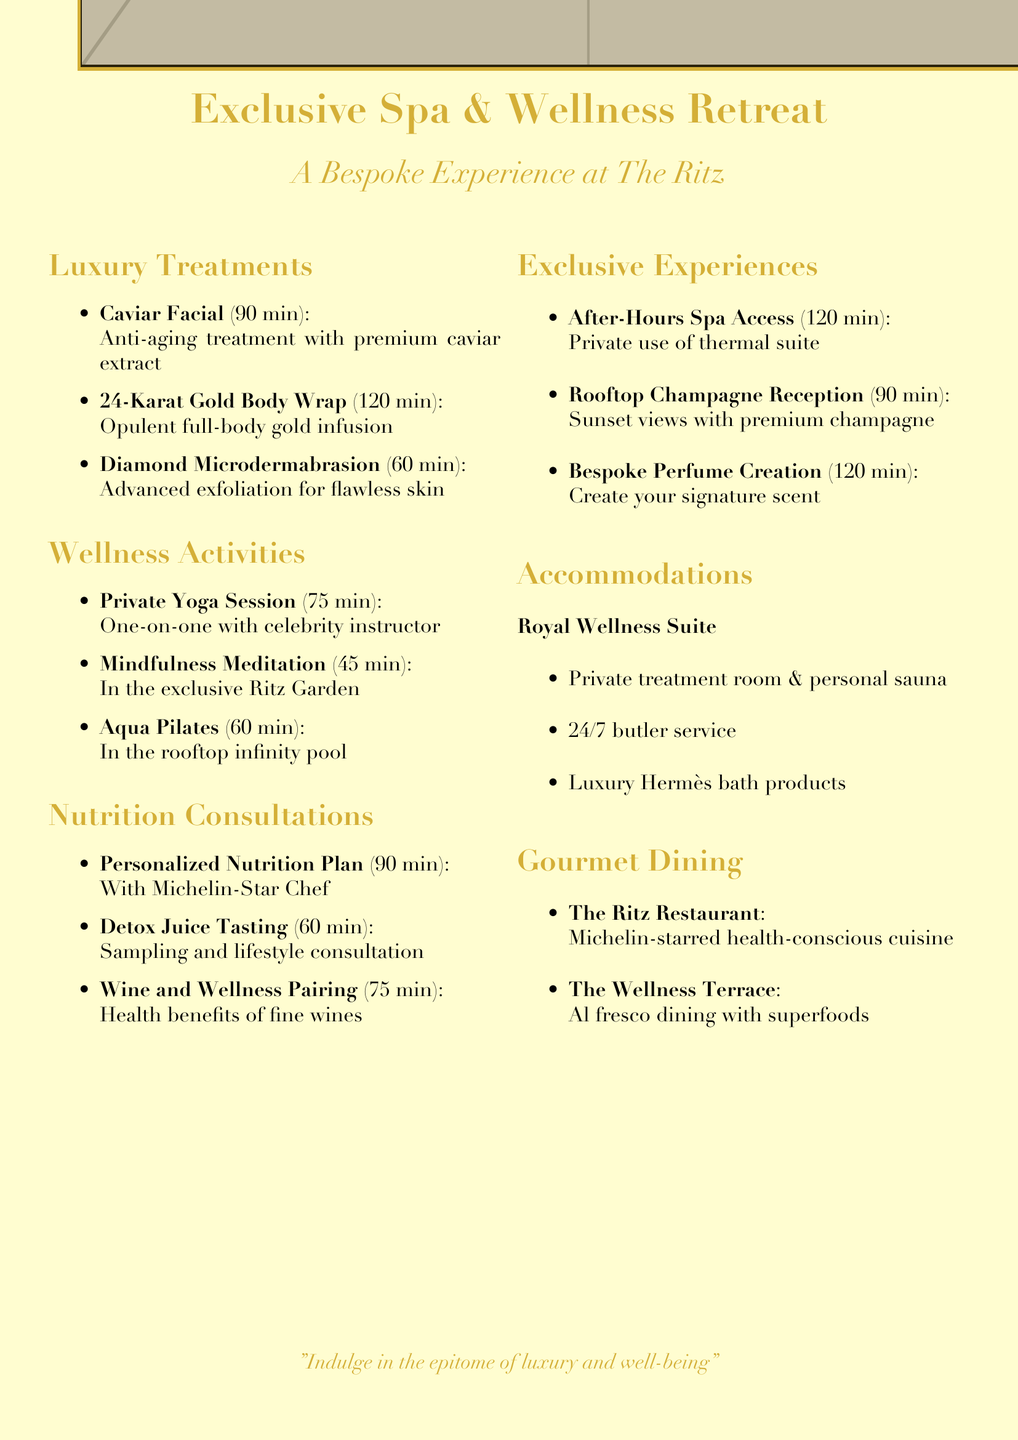What is the duration of the Caviar Facial? The duration of the Caviar Facial is specified as 90 minutes.
Answer: 90 minutes How long is the Private Yoga Session? The duration of the Private Yoga Session is mentioned as 75 minutes.
Answer: 75 minutes What type of expert provides the Personalized Nutrition Plan? The Personalized Nutrition Plan is created with a Michelin-Star Chef.
Answer: Michelin-Star Chef What exclusive experience involves the thermal suite? The exclusive experience that involves the thermal suite is the After-Hours Spa Access.
Answer: After-Hours Spa Access How many minutes is the Aqua Pilates session? The Aqua Pilates session duration is listed as 60 minutes.
Answer: 60 minutes Which dining option offers an organic tasting menu? The Ritz Restaurant features an organic tasting menu with wine pairing.
Answer: The Ritz Restaurant What unique accommodation is provided for guests? The unique accommodation offered is the Royal Wellness Suite.
Answer: Royal Wellness Suite What is the duration of the Rooftop Sunset Champagne Reception? The duration of the Rooftop Sunset Champagne Reception is specified as 90 minutes.
Answer: 90 minutes What type of treatment is the 24-Karat Gold Body Wrap? The 24-Karat Gold Body Wrap is classified as an opulent full-body treatment.
Answer: Opulent full-body treatment 